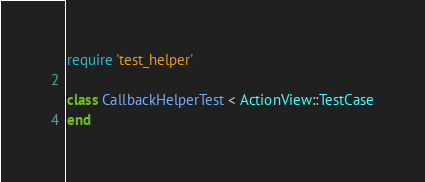<code> <loc_0><loc_0><loc_500><loc_500><_Ruby_>require 'test_helper'

class CallbackHelperTest < ActionView::TestCase
end
</code> 